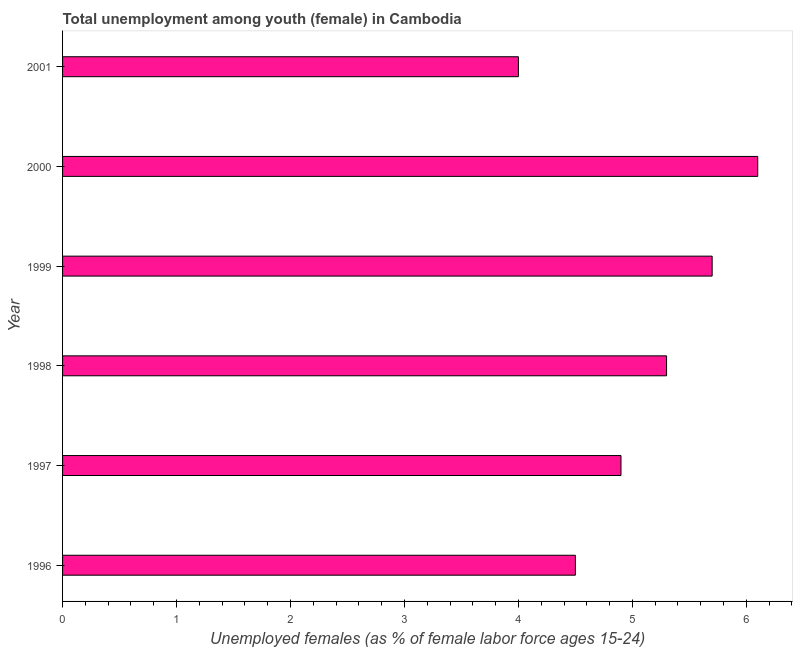What is the title of the graph?
Offer a very short reply. Total unemployment among youth (female) in Cambodia. What is the label or title of the X-axis?
Offer a terse response. Unemployed females (as % of female labor force ages 15-24). What is the label or title of the Y-axis?
Provide a succinct answer. Year. What is the unemployed female youth population in 2001?
Your answer should be compact. 4. Across all years, what is the maximum unemployed female youth population?
Offer a very short reply. 6.1. Across all years, what is the minimum unemployed female youth population?
Give a very brief answer. 4. In which year was the unemployed female youth population minimum?
Keep it short and to the point. 2001. What is the sum of the unemployed female youth population?
Offer a terse response. 30.5. What is the average unemployed female youth population per year?
Your answer should be very brief. 5.08. What is the median unemployed female youth population?
Ensure brevity in your answer.  5.1. Do a majority of the years between 1998 and 2001 (inclusive) have unemployed female youth population greater than 1 %?
Make the answer very short. Yes. What is the ratio of the unemployed female youth population in 2000 to that in 2001?
Your answer should be compact. 1.52. What is the difference between the highest and the second highest unemployed female youth population?
Provide a short and direct response. 0.4. What is the difference between the highest and the lowest unemployed female youth population?
Provide a short and direct response. 2.1. How many years are there in the graph?
Ensure brevity in your answer.  6. What is the Unemployed females (as % of female labor force ages 15-24) of 1996?
Make the answer very short. 4.5. What is the Unemployed females (as % of female labor force ages 15-24) of 1997?
Ensure brevity in your answer.  4.9. What is the Unemployed females (as % of female labor force ages 15-24) of 1998?
Keep it short and to the point. 5.3. What is the Unemployed females (as % of female labor force ages 15-24) of 1999?
Offer a terse response. 5.7. What is the Unemployed females (as % of female labor force ages 15-24) of 2000?
Offer a very short reply. 6.1. What is the Unemployed females (as % of female labor force ages 15-24) of 2001?
Give a very brief answer. 4. What is the difference between the Unemployed females (as % of female labor force ages 15-24) in 1996 and 1998?
Keep it short and to the point. -0.8. What is the difference between the Unemployed females (as % of female labor force ages 15-24) in 1996 and 1999?
Offer a terse response. -1.2. What is the difference between the Unemployed females (as % of female labor force ages 15-24) in 1996 and 2000?
Provide a succinct answer. -1.6. What is the difference between the Unemployed females (as % of female labor force ages 15-24) in 1997 and 1999?
Make the answer very short. -0.8. What is the difference between the Unemployed females (as % of female labor force ages 15-24) in 1998 and 1999?
Your response must be concise. -0.4. What is the difference between the Unemployed females (as % of female labor force ages 15-24) in 1998 and 2000?
Give a very brief answer. -0.8. What is the ratio of the Unemployed females (as % of female labor force ages 15-24) in 1996 to that in 1997?
Your response must be concise. 0.92. What is the ratio of the Unemployed females (as % of female labor force ages 15-24) in 1996 to that in 1998?
Your answer should be very brief. 0.85. What is the ratio of the Unemployed females (as % of female labor force ages 15-24) in 1996 to that in 1999?
Give a very brief answer. 0.79. What is the ratio of the Unemployed females (as % of female labor force ages 15-24) in 1996 to that in 2000?
Ensure brevity in your answer.  0.74. What is the ratio of the Unemployed females (as % of female labor force ages 15-24) in 1997 to that in 1998?
Your response must be concise. 0.93. What is the ratio of the Unemployed females (as % of female labor force ages 15-24) in 1997 to that in 1999?
Give a very brief answer. 0.86. What is the ratio of the Unemployed females (as % of female labor force ages 15-24) in 1997 to that in 2000?
Give a very brief answer. 0.8. What is the ratio of the Unemployed females (as % of female labor force ages 15-24) in 1997 to that in 2001?
Provide a succinct answer. 1.23. What is the ratio of the Unemployed females (as % of female labor force ages 15-24) in 1998 to that in 2000?
Your answer should be very brief. 0.87. What is the ratio of the Unemployed females (as % of female labor force ages 15-24) in 1998 to that in 2001?
Offer a very short reply. 1.32. What is the ratio of the Unemployed females (as % of female labor force ages 15-24) in 1999 to that in 2000?
Offer a terse response. 0.93. What is the ratio of the Unemployed females (as % of female labor force ages 15-24) in 1999 to that in 2001?
Provide a succinct answer. 1.43. What is the ratio of the Unemployed females (as % of female labor force ages 15-24) in 2000 to that in 2001?
Make the answer very short. 1.52. 